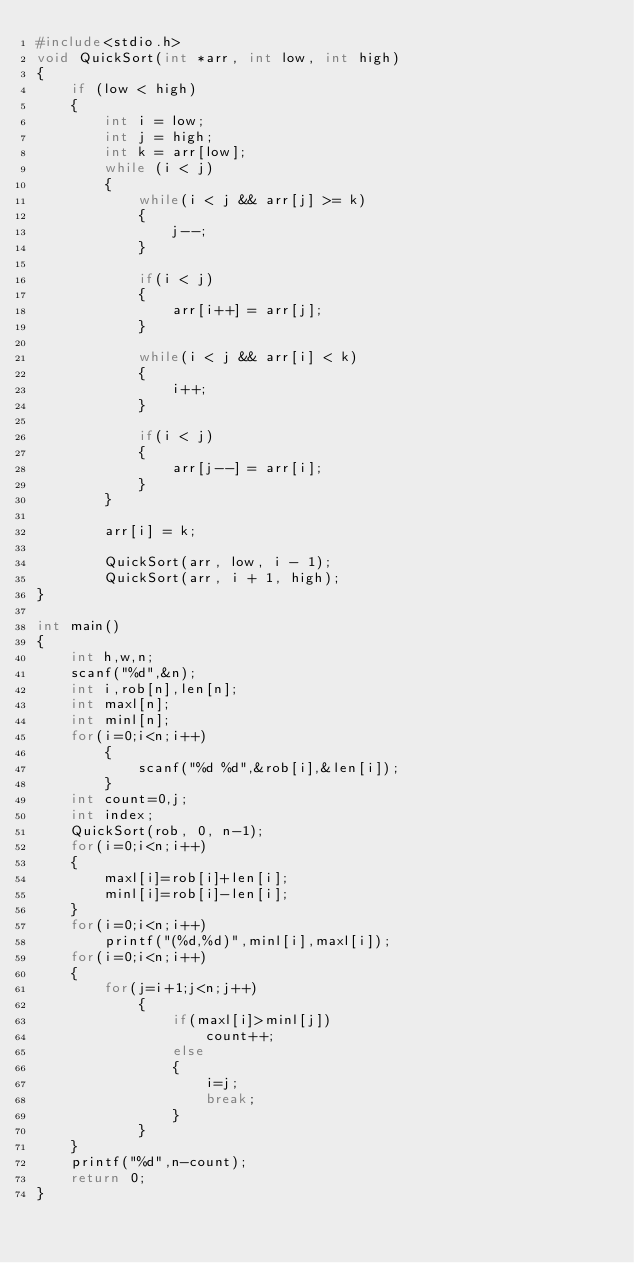Convert code to text. <code><loc_0><loc_0><loc_500><loc_500><_C++_>#include<stdio.h>
void QuickSort(int *arr, int low, int high)
{
    if (low < high)
    {
        int i = low;
        int j = high;
        int k = arr[low];
        while (i < j)
        {
            while(i < j && arr[j] >= k)   
            {
                j--;
            }

            if(i < j)
            {
                arr[i++] = arr[j];
            }

            while(i < j && arr[i] < k)    
            {
                i++;
            }

            if(i < j)
            {
                arr[j--] = arr[i];
            }
        }

        arr[i] = k;

        QuickSort(arr, low, i - 1);     
        QuickSort(arr, i + 1, high);    
}

int main()
{
    int h,w,n;
    scanf("%d",&n);
    int i,rob[n],len[n];
    int maxl[n];
    int minl[n];
    for(i=0;i<n;i++)
        {
            scanf("%d %d",&rob[i],&len[i]);
        }
    int count=0,j;
    int index;
    QuickSort(rob, 0, n-1);
    for(i=0;i<n;i++)
    {
        maxl[i]=rob[i]+len[i];
        minl[i]=rob[i]-len[i];
    }
    for(i=0;i<n;i++)
        printf("(%d,%d)",minl[i],maxl[i]);
    for(i=0;i<n;i++)
    {
        for(j=i+1;j<n;j++)
            {
                if(maxl[i]>minl[j])
                    count++;
                else
                {
                    i=j;
                    break;
                }
            }
    }
    printf("%d",n-count);
    return 0;
}
</code> 